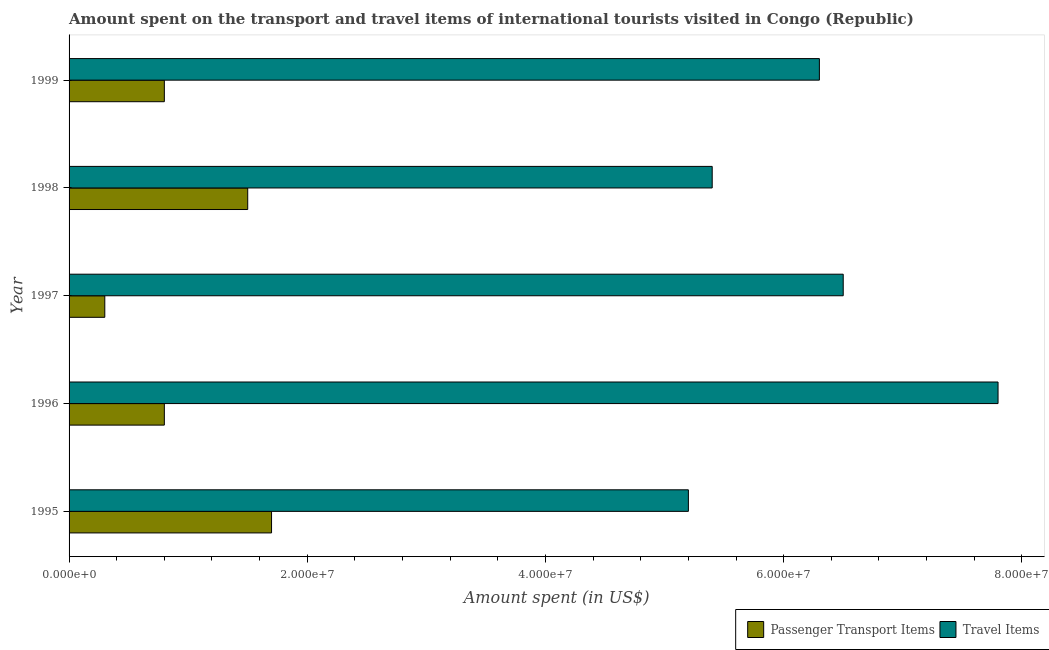How many different coloured bars are there?
Make the answer very short. 2. How many groups of bars are there?
Your answer should be very brief. 5. Are the number of bars per tick equal to the number of legend labels?
Your response must be concise. Yes. What is the label of the 4th group of bars from the top?
Make the answer very short. 1996. In how many cases, is the number of bars for a given year not equal to the number of legend labels?
Provide a short and direct response. 0. What is the amount spent in travel items in 1996?
Keep it short and to the point. 7.80e+07. Across all years, what is the maximum amount spent on passenger transport items?
Keep it short and to the point. 1.70e+07. Across all years, what is the minimum amount spent in travel items?
Offer a terse response. 5.20e+07. What is the total amount spent on passenger transport items in the graph?
Provide a succinct answer. 5.10e+07. What is the difference between the amount spent on passenger transport items in 1995 and that in 1996?
Provide a succinct answer. 9.00e+06. What is the difference between the amount spent on passenger transport items in 1997 and the amount spent in travel items in 1995?
Provide a succinct answer. -4.90e+07. What is the average amount spent on passenger transport items per year?
Provide a succinct answer. 1.02e+07. In the year 1999, what is the difference between the amount spent on passenger transport items and amount spent in travel items?
Ensure brevity in your answer.  -5.50e+07. What is the ratio of the amount spent on passenger transport items in 1996 to that in 1998?
Your response must be concise. 0.53. What is the difference between the highest and the second highest amount spent in travel items?
Your answer should be very brief. 1.30e+07. What is the difference between the highest and the lowest amount spent in travel items?
Ensure brevity in your answer.  2.60e+07. What does the 2nd bar from the top in 1996 represents?
Make the answer very short. Passenger Transport Items. What does the 2nd bar from the bottom in 1996 represents?
Provide a short and direct response. Travel Items. How many years are there in the graph?
Offer a very short reply. 5. What is the difference between two consecutive major ticks on the X-axis?
Your response must be concise. 2.00e+07. Are the values on the major ticks of X-axis written in scientific E-notation?
Offer a terse response. Yes. How are the legend labels stacked?
Make the answer very short. Horizontal. What is the title of the graph?
Offer a very short reply. Amount spent on the transport and travel items of international tourists visited in Congo (Republic). What is the label or title of the X-axis?
Your answer should be very brief. Amount spent (in US$). What is the Amount spent (in US$) of Passenger Transport Items in 1995?
Provide a succinct answer. 1.70e+07. What is the Amount spent (in US$) in Travel Items in 1995?
Provide a succinct answer. 5.20e+07. What is the Amount spent (in US$) in Passenger Transport Items in 1996?
Provide a short and direct response. 8.00e+06. What is the Amount spent (in US$) of Travel Items in 1996?
Your response must be concise. 7.80e+07. What is the Amount spent (in US$) of Passenger Transport Items in 1997?
Provide a short and direct response. 3.00e+06. What is the Amount spent (in US$) in Travel Items in 1997?
Give a very brief answer. 6.50e+07. What is the Amount spent (in US$) in Passenger Transport Items in 1998?
Your answer should be compact. 1.50e+07. What is the Amount spent (in US$) of Travel Items in 1998?
Your answer should be very brief. 5.40e+07. What is the Amount spent (in US$) in Passenger Transport Items in 1999?
Keep it short and to the point. 8.00e+06. What is the Amount spent (in US$) in Travel Items in 1999?
Keep it short and to the point. 6.30e+07. Across all years, what is the maximum Amount spent (in US$) in Passenger Transport Items?
Keep it short and to the point. 1.70e+07. Across all years, what is the maximum Amount spent (in US$) of Travel Items?
Provide a succinct answer. 7.80e+07. Across all years, what is the minimum Amount spent (in US$) in Travel Items?
Give a very brief answer. 5.20e+07. What is the total Amount spent (in US$) in Passenger Transport Items in the graph?
Give a very brief answer. 5.10e+07. What is the total Amount spent (in US$) in Travel Items in the graph?
Ensure brevity in your answer.  3.12e+08. What is the difference between the Amount spent (in US$) in Passenger Transport Items in 1995 and that in 1996?
Provide a short and direct response. 9.00e+06. What is the difference between the Amount spent (in US$) of Travel Items in 1995 and that in 1996?
Provide a short and direct response. -2.60e+07. What is the difference between the Amount spent (in US$) of Passenger Transport Items in 1995 and that in 1997?
Your answer should be compact. 1.40e+07. What is the difference between the Amount spent (in US$) of Travel Items in 1995 and that in 1997?
Give a very brief answer. -1.30e+07. What is the difference between the Amount spent (in US$) of Passenger Transport Items in 1995 and that in 1998?
Your response must be concise. 2.00e+06. What is the difference between the Amount spent (in US$) in Passenger Transport Items in 1995 and that in 1999?
Your answer should be compact. 9.00e+06. What is the difference between the Amount spent (in US$) in Travel Items in 1995 and that in 1999?
Give a very brief answer. -1.10e+07. What is the difference between the Amount spent (in US$) in Passenger Transport Items in 1996 and that in 1997?
Your answer should be compact. 5.00e+06. What is the difference between the Amount spent (in US$) in Travel Items in 1996 and that in 1997?
Offer a very short reply. 1.30e+07. What is the difference between the Amount spent (in US$) in Passenger Transport Items in 1996 and that in 1998?
Make the answer very short. -7.00e+06. What is the difference between the Amount spent (in US$) of Travel Items in 1996 and that in 1998?
Offer a very short reply. 2.40e+07. What is the difference between the Amount spent (in US$) of Passenger Transport Items in 1996 and that in 1999?
Keep it short and to the point. 0. What is the difference between the Amount spent (in US$) of Travel Items in 1996 and that in 1999?
Keep it short and to the point. 1.50e+07. What is the difference between the Amount spent (in US$) of Passenger Transport Items in 1997 and that in 1998?
Ensure brevity in your answer.  -1.20e+07. What is the difference between the Amount spent (in US$) of Travel Items in 1997 and that in 1998?
Provide a short and direct response. 1.10e+07. What is the difference between the Amount spent (in US$) of Passenger Transport Items in 1997 and that in 1999?
Your answer should be very brief. -5.00e+06. What is the difference between the Amount spent (in US$) in Travel Items in 1997 and that in 1999?
Your answer should be compact. 2.00e+06. What is the difference between the Amount spent (in US$) in Travel Items in 1998 and that in 1999?
Your answer should be very brief. -9.00e+06. What is the difference between the Amount spent (in US$) of Passenger Transport Items in 1995 and the Amount spent (in US$) of Travel Items in 1996?
Provide a succinct answer. -6.10e+07. What is the difference between the Amount spent (in US$) of Passenger Transport Items in 1995 and the Amount spent (in US$) of Travel Items in 1997?
Provide a succinct answer. -4.80e+07. What is the difference between the Amount spent (in US$) in Passenger Transport Items in 1995 and the Amount spent (in US$) in Travel Items in 1998?
Offer a very short reply. -3.70e+07. What is the difference between the Amount spent (in US$) in Passenger Transport Items in 1995 and the Amount spent (in US$) in Travel Items in 1999?
Offer a terse response. -4.60e+07. What is the difference between the Amount spent (in US$) of Passenger Transport Items in 1996 and the Amount spent (in US$) of Travel Items in 1997?
Make the answer very short. -5.70e+07. What is the difference between the Amount spent (in US$) of Passenger Transport Items in 1996 and the Amount spent (in US$) of Travel Items in 1998?
Ensure brevity in your answer.  -4.60e+07. What is the difference between the Amount spent (in US$) in Passenger Transport Items in 1996 and the Amount spent (in US$) in Travel Items in 1999?
Offer a very short reply. -5.50e+07. What is the difference between the Amount spent (in US$) of Passenger Transport Items in 1997 and the Amount spent (in US$) of Travel Items in 1998?
Your response must be concise. -5.10e+07. What is the difference between the Amount spent (in US$) in Passenger Transport Items in 1997 and the Amount spent (in US$) in Travel Items in 1999?
Your answer should be very brief. -6.00e+07. What is the difference between the Amount spent (in US$) in Passenger Transport Items in 1998 and the Amount spent (in US$) in Travel Items in 1999?
Give a very brief answer. -4.80e+07. What is the average Amount spent (in US$) in Passenger Transport Items per year?
Make the answer very short. 1.02e+07. What is the average Amount spent (in US$) of Travel Items per year?
Offer a terse response. 6.24e+07. In the year 1995, what is the difference between the Amount spent (in US$) in Passenger Transport Items and Amount spent (in US$) in Travel Items?
Give a very brief answer. -3.50e+07. In the year 1996, what is the difference between the Amount spent (in US$) in Passenger Transport Items and Amount spent (in US$) in Travel Items?
Keep it short and to the point. -7.00e+07. In the year 1997, what is the difference between the Amount spent (in US$) of Passenger Transport Items and Amount spent (in US$) of Travel Items?
Offer a very short reply. -6.20e+07. In the year 1998, what is the difference between the Amount spent (in US$) in Passenger Transport Items and Amount spent (in US$) in Travel Items?
Make the answer very short. -3.90e+07. In the year 1999, what is the difference between the Amount spent (in US$) in Passenger Transport Items and Amount spent (in US$) in Travel Items?
Make the answer very short. -5.50e+07. What is the ratio of the Amount spent (in US$) of Passenger Transport Items in 1995 to that in 1996?
Provide a succinct answer. 2.12. What is the ratio of the Amount spent (in US$) in Passenger Transport Items in 1995 to that in 1997?
Keep it short and to the point. 5.67. What is the ratio of the Amount spent (in US$) of Passenger Transport Items in 1995 to that in 1998?
Give a very brief answer. 1.13. What is the ratio of the Amount spent (in US$) of Passenger Transport Items in 1995 to that in 1999?
Your answer should be very brief. 2.12. What is the ratio of the Amount spent (in US$) in Travel Items in 1995 to that in 1999?
Offer a terse response. 0.83. What is the ratio of the Amount spent (in US$) in Passenger Transport Items in 1996 to that in 1997?
Make the answer very short. 2.67. What is the ratio of the Amount spent (in US$) of Passenger Transport Items in 1996 to that in 1998?
Keep it short and to the point. 0.53. What is the ratio of the Amount spent (in US$) of Travel Items in 1996 to that in 1998?
Ensure brevity in your answer.  1.44. What is the ratio of the Amount spent (in US$) in Passenger Transport Items in 1996 to that in 1999?
Make the answer very short. 1. What is the ratio of the Amount spent (in US$) of Travel Items in 1996 to that in 1999?
Offer a terse response. 1.24. What is the ratio of the Amount spent (in US$) in Travel Items in 1997 to that in 1998?
Ensure brevity in your answer.  1.2. What is the ratio of the Amount spent (in US$) in Passenger Transport Items in 1997 to that in 1999?
Your answer should be compact. 0.38. What is the ratio of the Amount spent (in US$) of Travel Items in 1997 to that in 1999?
Make the answer very short. 1.03. What is the ratio of the Amount spent (in US$) in Passenger Transport Items in 1998 to that in 1999?
Give a very brief answer. 1.88. What is the ratio of the Amount spent (in US$) of Travel Items in 1998 to that in 1999?
Give a very brief answer. 0.86. What is the difference between the highest and the second highest Amount spent (in US$) in Passenger Transport Items?
Ensure brevity in your answer.  2.00e+06. What is the difference between the highest and the second highest Amount spent (in US$) of Travel Items?
Your answer should be very brief. 1.30e+07. What is the difference between the highest and the lowest Amount spent (in US$) in Passenger Transport Items?
Your answer should be compact. 1.40e+07. What is the difference between the highest and the lowest Amount spent (in US$) of Travel Items?
Offer a terse response. 2.60e+07. 